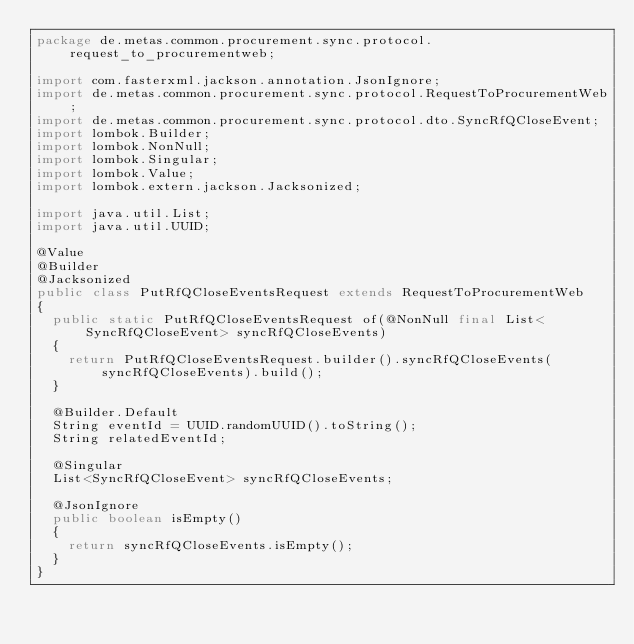<code> <loc_0><loc_0><loc_500><loc_500><_Java_>package de.metas.common.procurement.sync.protocol.request_to_procurementweb;

import com.fasterxml.jackson.annotation.JsonIgnore;
import de.metas.common.procurement.sync.protocol.RequestToProcurementWeb;
import de.metas.common.procurement.sync.protocol.dto.SyncRfQCloseEvent;
import lombok.Builder;
import lombok.NonNull;
import lombok.Singular;
import lombok.Value;
import lombok.extern.jackson.Jacksonized;

import java.util.List;
import java.util.UUID;

@Value
@Builder
@Jacksonized
public class PutRfQCloseEventsRequest extends RequestToProcurementWeb
{
	public static PutRfQCloseEventsRequest of(@NonNull final List<SyncRfQCloseEvent> syncRfQCloseEvents)
	{
		return PutRfQCloseEventsRequest.builder().syncRfQCloseEvents(syncRfQCloseEvents).build();
	}

	@Builder.Default
	String eventId = UUID.randomUUID().toString();
	String relatedEventId;

	@Singular
	List<SyncRfQCloseEvent> syncRfQCloseEvents;

	@JsonIgnore
	public boolean isEmpty()
	{
		return syncRfQCloseEvents.isEmpty();
	}
}
</code> 